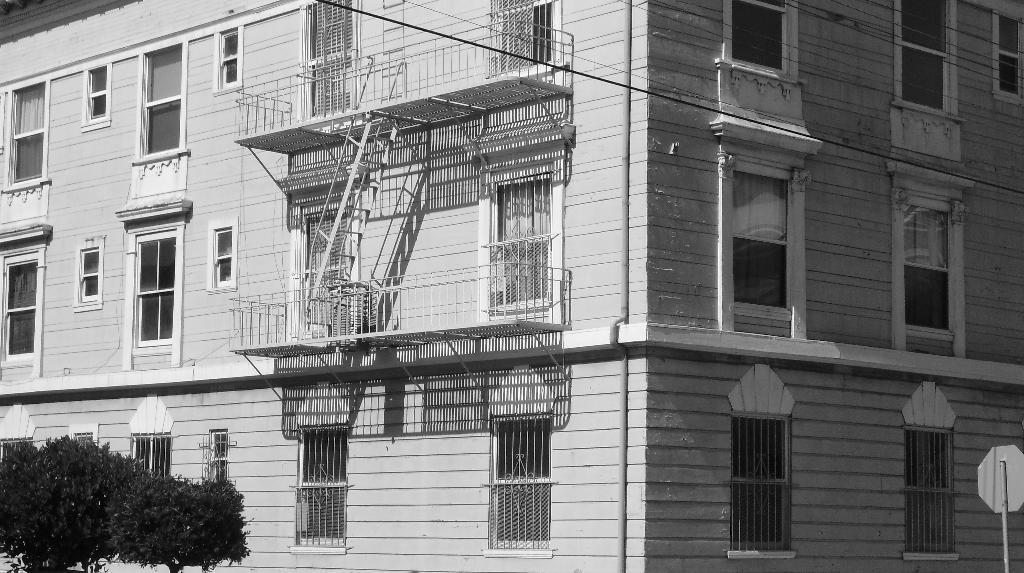Can you describe this image briefly? This is a black and white image where we can see a building. There is a board on the right side of the image. We can see trees in the left top of the image. 